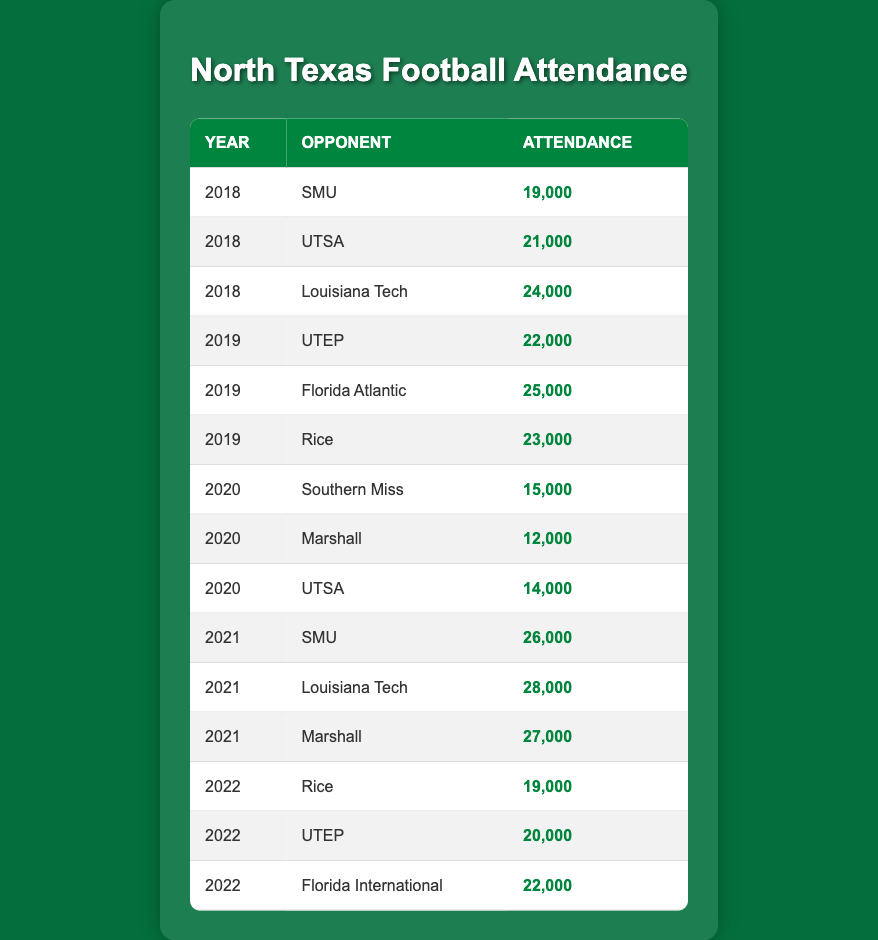What was the attendance for North Texas football games against Louisiana Tech in 2018 and 2021? The attendance figures for Louisiana Tech in 2018 is 24,000 and in 2021 it's 28,000 as seen in the respective rows of the table.
Answer: 24,000 in 2018 and 28,000 in 2021 Which opponent had the highest attendance in 2021? From the table, the maximum attendance in 2021 is found in the row for Louisiana Tech with 28,000 fans.
Answer: Louisiana Tech What is the total attendance for UTEP games from 2019 to 2022? The attendance for UTEP from the results is 22,000 in 2019, 20,000 in 2022. The total is calculated as 22,000 + 20,000 = 42,000.
Answer: 42,000 Did the attendance for North Texas games against SMU increase or decrease from 2018 to 2021? The attendance figures show 19,000 in 2018 and 26,000 in 2021 respectively. Since 26,000 is greater than 19,000, attendance increased.
Answer: Increased What was the average attendance for North Texas against all opponents in 2020? The attendance figures for 2020 are 15,000, 12,000, and 14,000. The total attendance is 15,000 + 12,000 + 14,000 = 41,000, and with 3 data points, the average is 41,000 / 3 = approximately 13,667.
Answer: 13,667 Which year saw the most significant drop in attendance compared to the previous year? In the year 2020, there was a drop in attendance from 2019 where the highest attendance was 25,000 in 2019 to a maximum of 15,000 in 2020 resulting in a decrease of 10,000.
Answer: 2020 What was the attendance at the Rice game in 2022? The attendance figure for the game against Rice in 2022 is explicitly listed in the table as 19,000.
Answer: 19,000 Was the attendance against Southern Miss in 2020 less than 20,000? Yes, the table states the attendance for the Southern Miss game in 2020 was 15,000, which is less than 20,000.
Answer: Yes How much did the attendance against UTEP increase from 2019 to 2022? The attendance against UTEP is noted as 22,000 in 2019 and 20,000 in 2022. This indicates a decrease of 2,000 from 2019 to 2022.
Answer: Decreased by 2,000 